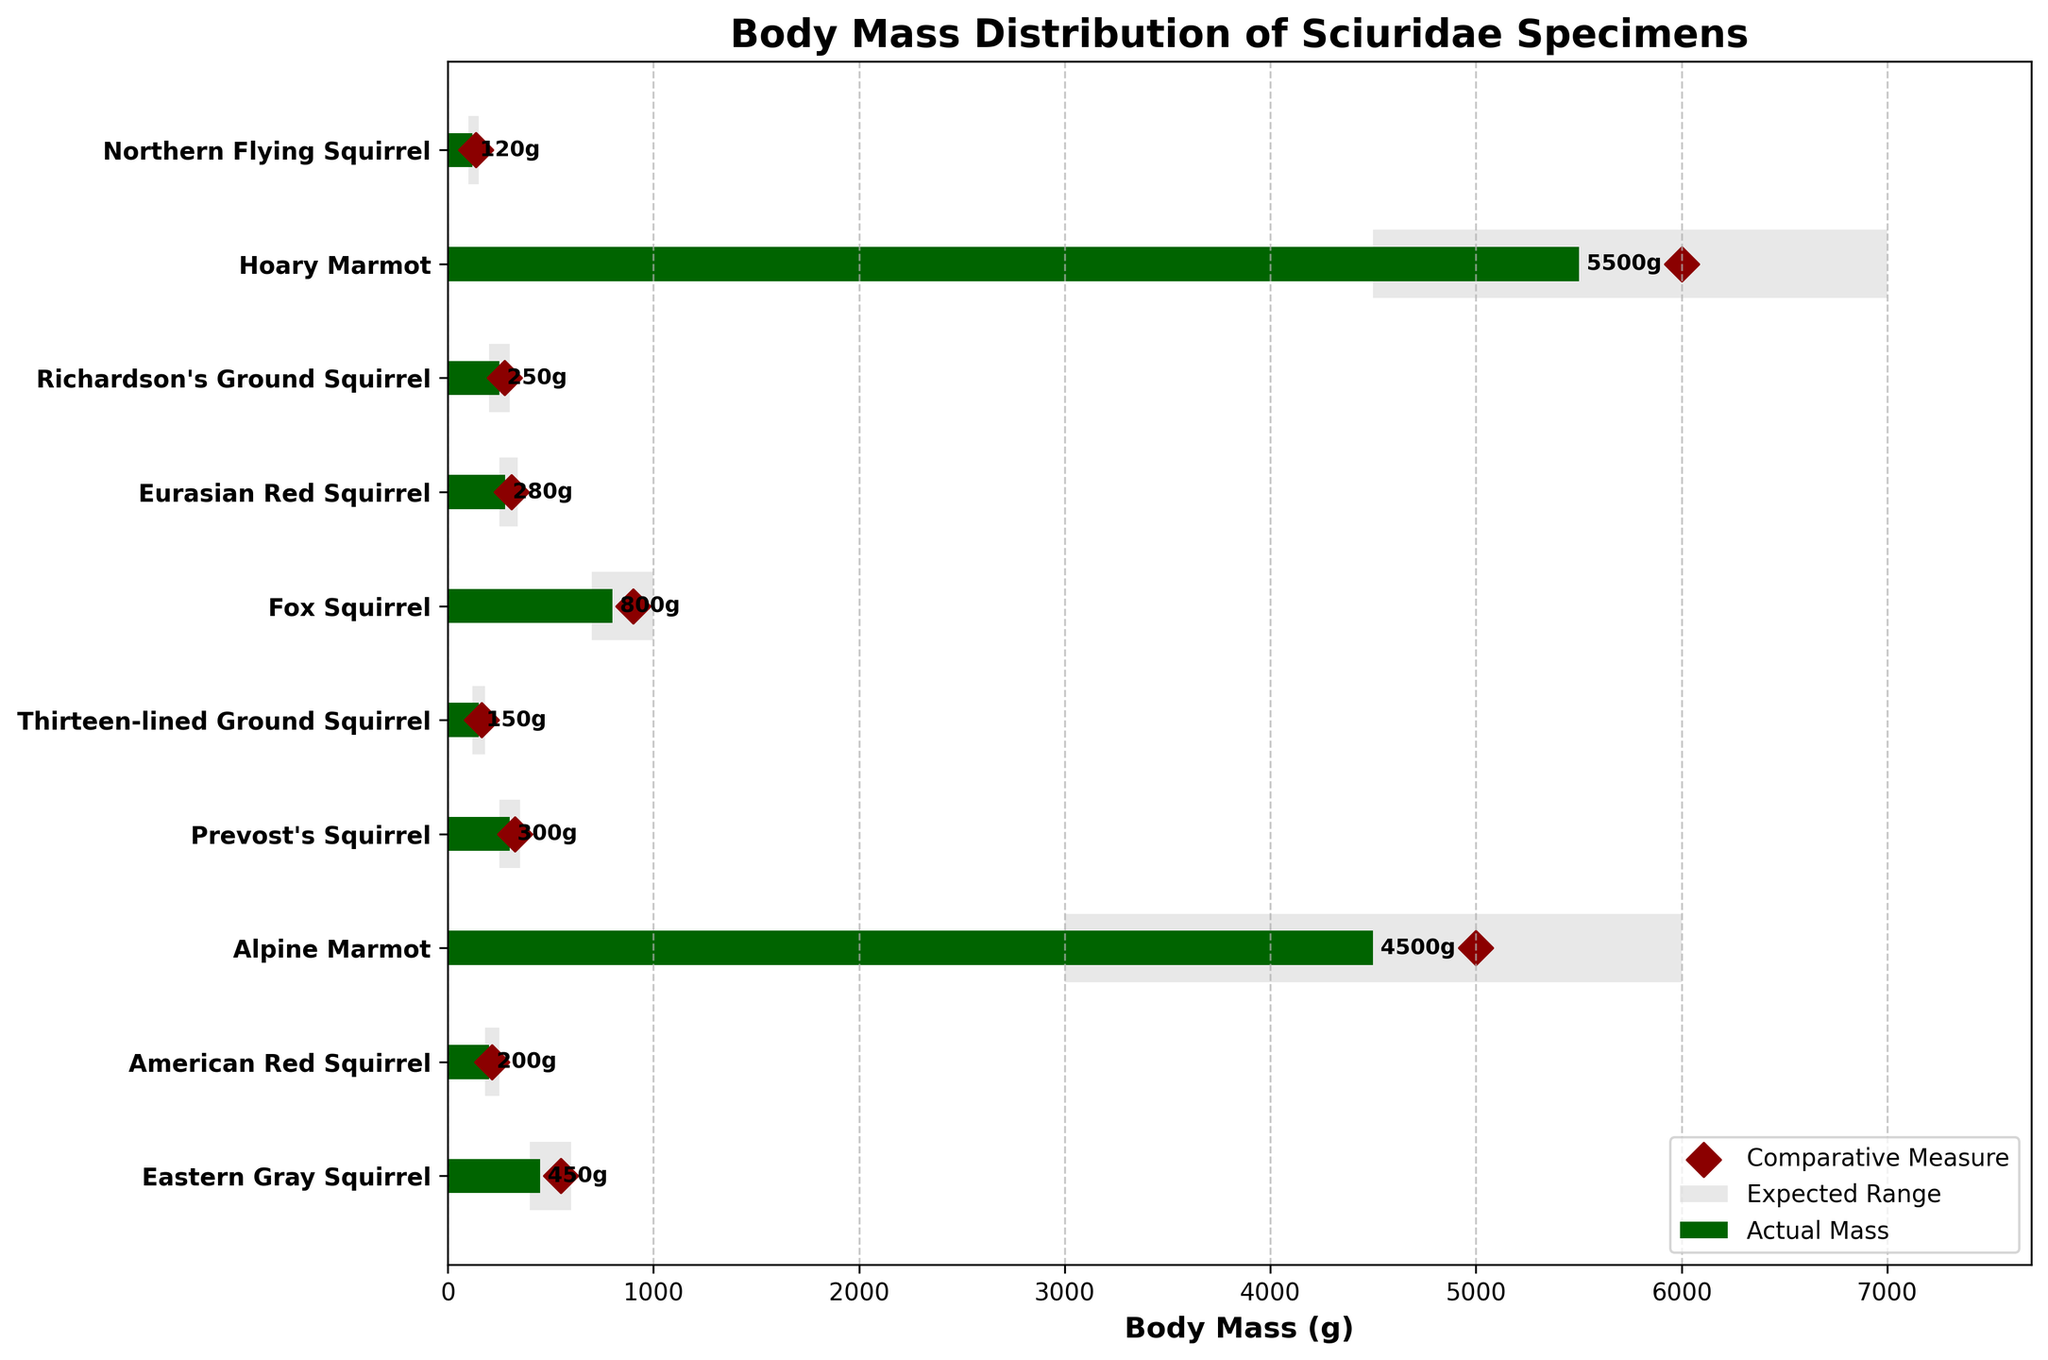How many species are plotted in the figure? Count the number of unique species listed on the y-axis. There are 10 distinct species shown on the vertical axis.
Answer: 10 What is the title of the figure? Look at the top of the figure where the title is located. The title is "Body Mass Distribution of Sciuridae Specimens."
Answer: Body Mass Distribution of Sciuridae Specimens What are the color representations for the expected range and actual mass in the plot? Identify the colors used in the plot. Light grey represents "Expected Range" and dark green represents "Actual Mass."
Answer: Light grey and dark green Which species has the highest actual body mass in the figure? Compare the actual mass values of all species. The Hoary Marmot has the highest actual body mass at 5500 grams.
Answer: Hoary Marmot Does the actual mass of the Eastern Gray Squirrel lie within its expected range? Check the actual mass of the Eastern Gray Squirrel and see if it falls between the expected range minimum and maximum. The actual mass of the Eastern Gray Squirrel is 450 grams, which lies within the expected range of 400 to 600 grams.
Answer: Yes What is the discrepancy between the actual mass and the comparative measure for the American Red Squirrel? Subtract the actual mass of the American Red Squirrel from its comparative measure. Comparative measure is 215 grams and actual mass is 200 grams, so the discrepancy is 215 - 200 = 15 grams.
Answer: 15 grams Which species has an actual mass exactly equal to the comparative measure? Verify if any species' actual mass matches its comparative measure. The Alpine Marmot has an actual mass of 4500 grams, which matches its comparative measure of 5000 grams.
Answer: None Is the actual body mass of the Fox Squirrel greater than its comparative measure? Compare the actual mass and comparative measure for the Fox Squirrel. The Fox Squirrel has an actual mass of 800 grams and a comparative measure of 900 grams, so its actual mass is not greater.
Answer: No Which species has the smallest difference between its expected range maximum and minimum? Calculate the differences between the expected range maximum and minimum for each species and find the smallest one. The Thirteen-lined Ground Squirrel has the smallest range difference of 60 grams (180 - 120).
Answer: Thirteen-lined Ground Squirrel What are the y-axis labels indicating in this chart? Observe the labels on the y-axis of the chart. The y-axis labels indicate different species of Sciuridae.
Answer: Species of Sciuridae 